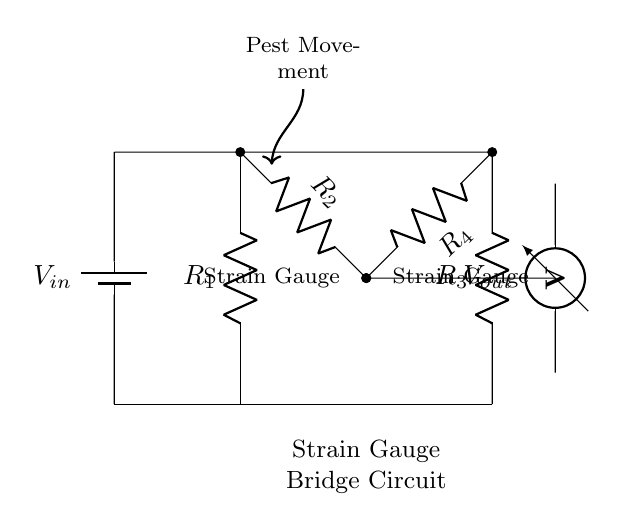What type of circuit is represented? The circuit is a strain gauge bridge circuit, recognizable by its arrangement of resistors in a bridge configuration used for measuring resistance changes due to strain.
Answer: Strain gauge bridge How many resistors are in the circuit? There are four resistors labeled R1, R2, R3, and R4, making it a total of four resistors in the bridge circuit.
Answer: Four What is the function of the strain gauges? The strain gauges, represented by resistors R2 and R4, detect changes in resistance caused by pest movement affecting the plant stems.
Answer: Detect pest movement What does Vout represent? Vout is the output voltage that indicates the difference in voltage across the bridge circuit, which alters due to variations in the resistance of the strain gauges.
Answer: Output voltage Why is there a battery in the circuit? The battery supplies a constant input voltage (Vin) necessary for the operation of the strain gauge bridge circuit to measure small resistance changes.
Answer: To provide input voltage If one strain gauge is affected by a pest, what happens to Vout? When a strain gauge is affected by pest movement, its resistance changes, causing an imbalance in the bridge and resulting in a measurable change in Vout, which indicates this movement.
Answer: Vout changes 